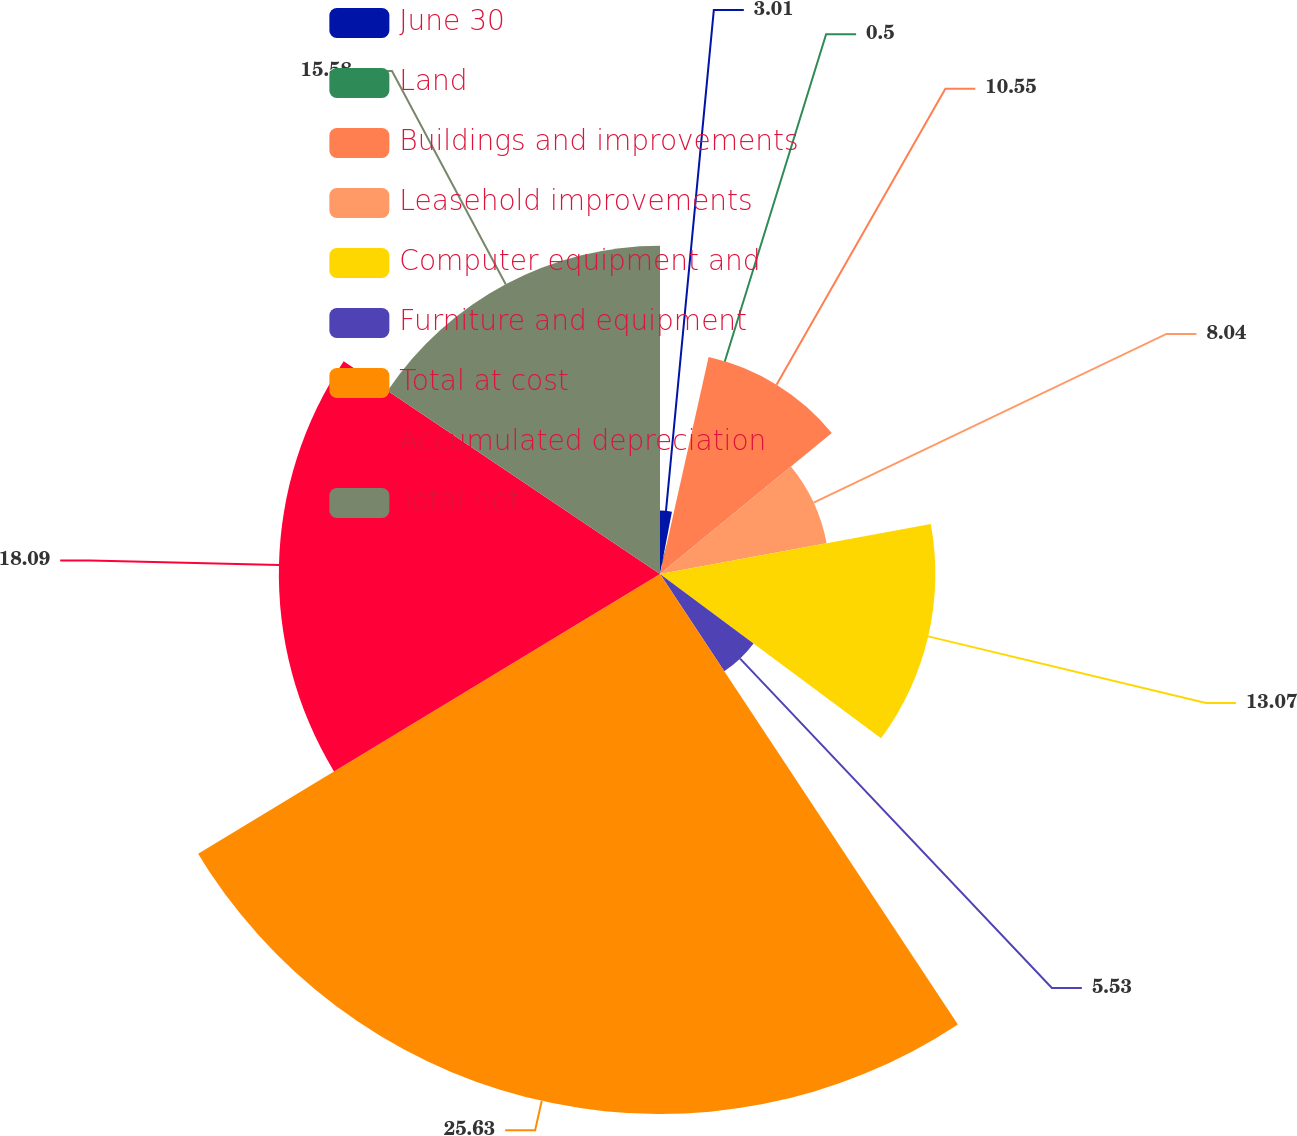Convert chart to OTSL. <chart><loc_0><loc_0><loc_500><loc_500><pie_chart><fcel>June 30<fcel>Land<fcel>Buildings and improvements<fcel>Leasehold improvements<fcel>Computer equipment and<fcel>Furniture and equipment<fcel>Total at cost<fcel>Accumulated depreciation<fcel>Total net<nl><fcel>3.01%<fcel>0.5%<fcel>10.55%<fcel>8.04%<fcel>13.07%<fcel>5.53%<fcel>25.63%<fcel>18.09%<fcel>15.58%<nl></chart> 